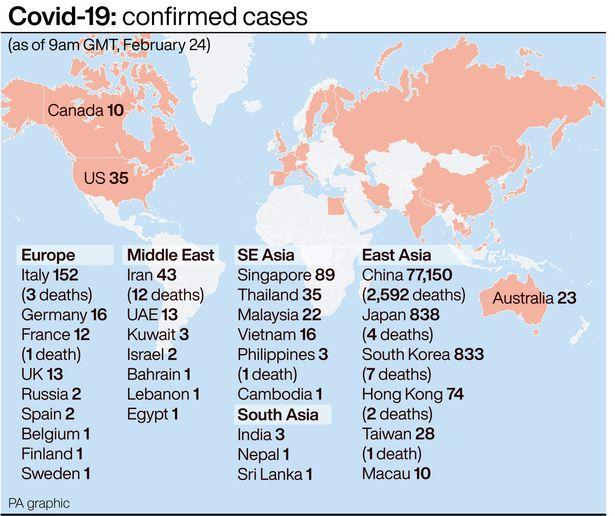In which country 4 deaths were reported till February 24th?
Answer the question with a short phrase. Japan In which country was the highest number of deaths reported till Feb 24? China How many deaths were reported in China till Feb 24? 2,592 Which Middle East country has the highest number of confirmed cases? Iran In which East Asian country was 7 deaths reported? South Korea How many deaths were reported in Iran? 12 Which country had the second highest number of confirmed cases worldwide as on Feb 24? Japan As of February 24, how many deaths were reported in Italy? 3 How many confirmed cases in the European country where the number deaths reported is 3? 152 In which country in SE Asia was 1 death reported? Philippines 